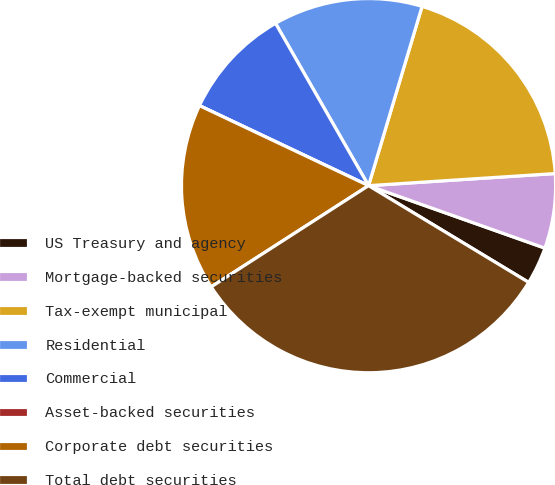Convert chart. <chart><loc_0><loc_0><loc_500><loc_500><pie_chart><fcel>US Treasury and agency<fcel>Mortgage-backed securities<fcel>Tax-exempt municipal<fcel>Residential<fcel>Commercial<fcel>Asset-backed securities<fcel>Corporate debt securities<fcel>Total debt securities<nl><fcel>3.23%<fcel>6.45%<fcel>19.35%<fcel>12.9%<fcel>9.68%<fcel>0.0%<fcel>16.13%<fcel>32.25%<nl></chart> 